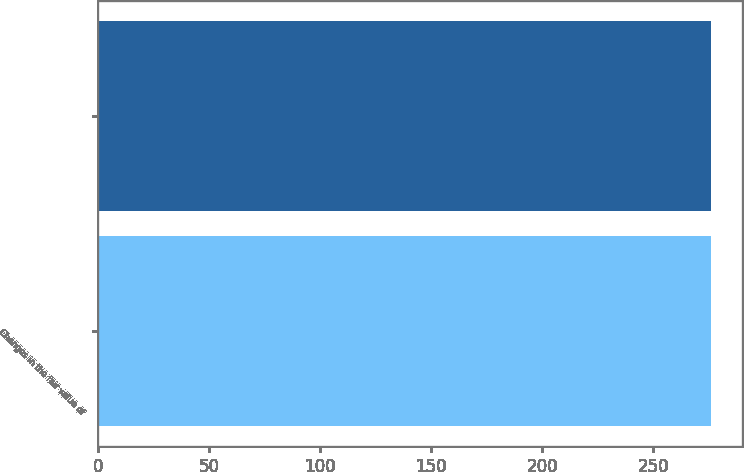<chart> <loc_0><loc_0><loc_500><loc_500><bar_chart><fcel>Changes in the fair value of<fcel>Unnamed: 1<nl><fcel>276<fcel>276.1<nl></chart> 